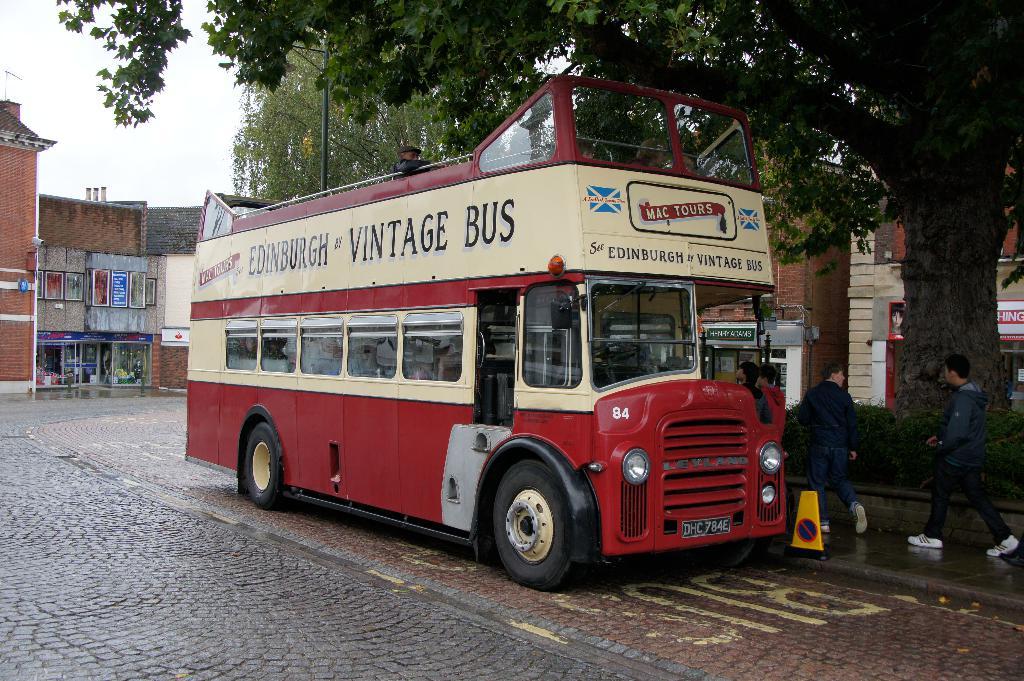What is the name of the tour company?
Keep it short and to the point. Mac tours. What is the license number of the buss?
Ensure brevity in your answer.  Dhc784e. 